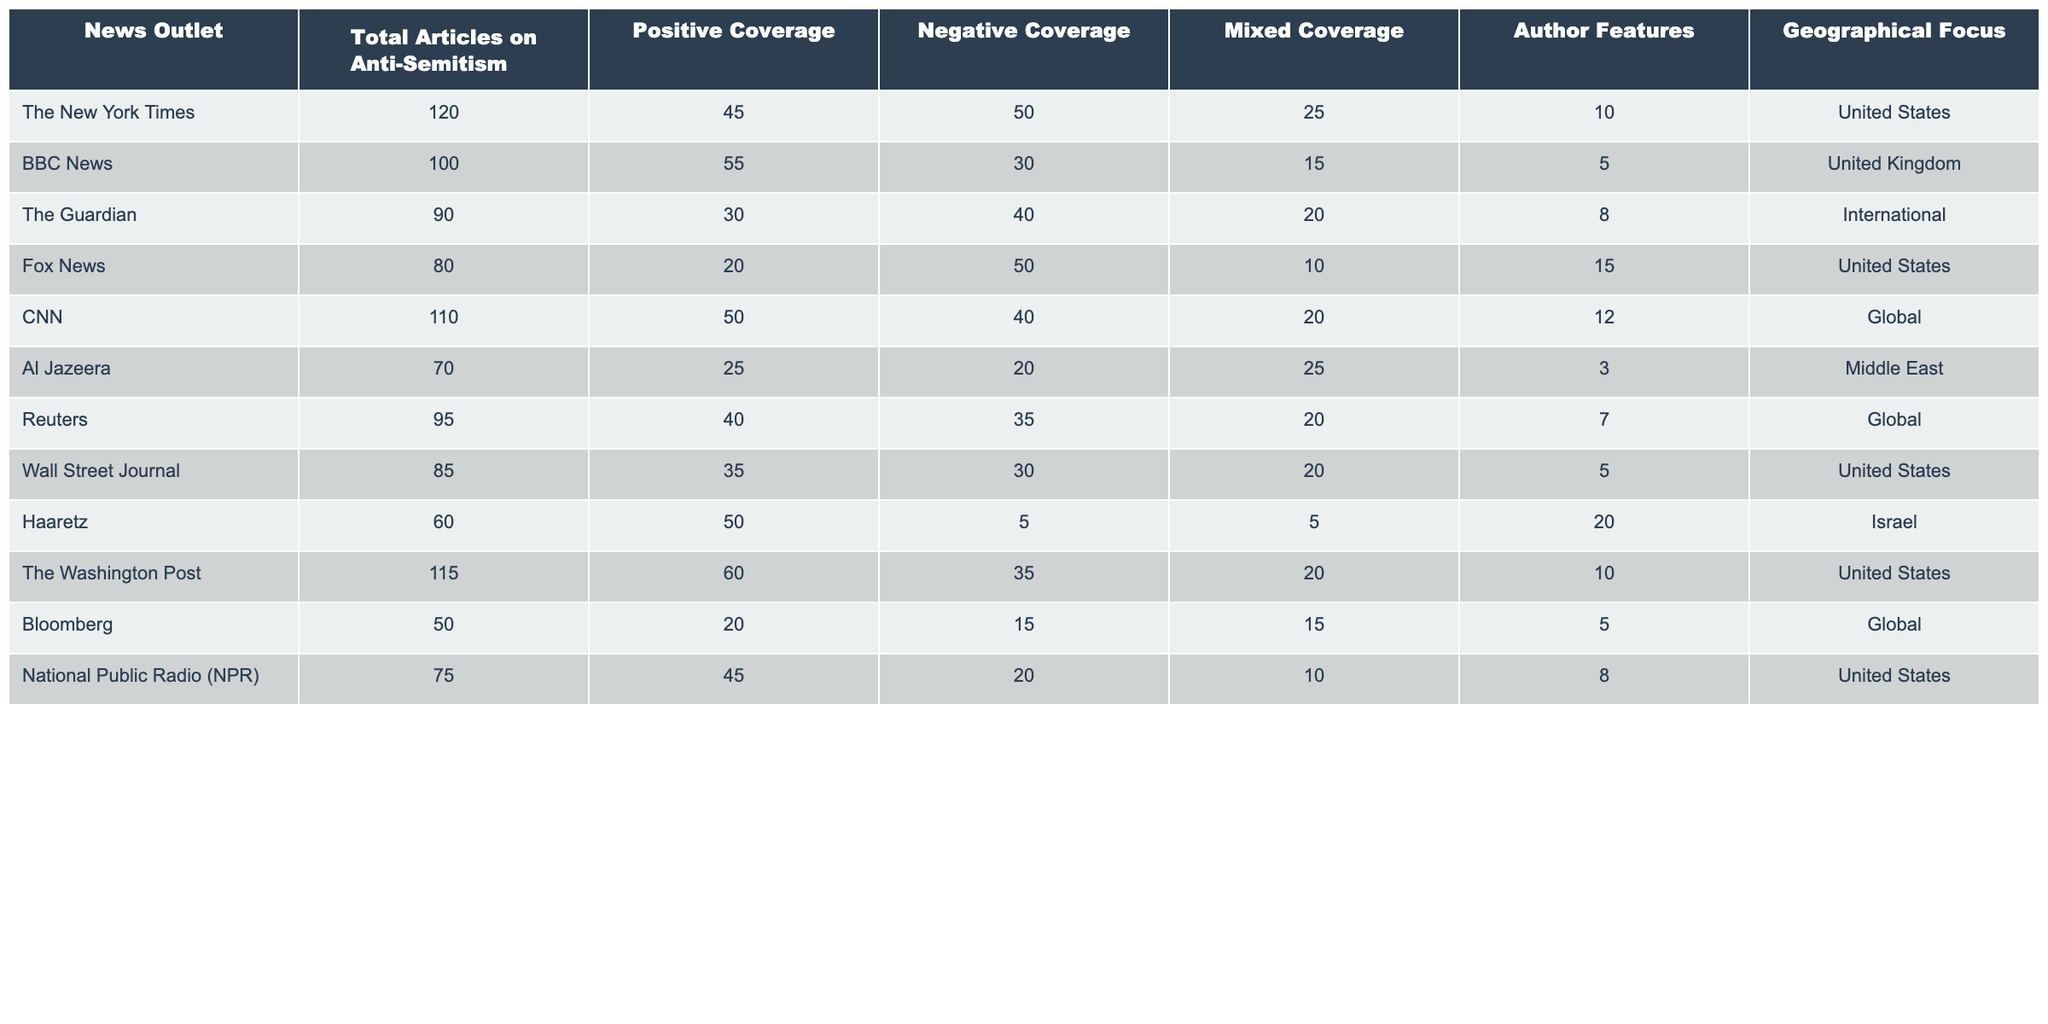What is the total number of articles on anti-Semitism published by The New York Times? The table shows that The New York Times published 120 articles on anti-Semitism.
Answer: 120 Which news outlet had the highest positive coverage of anti-Semitism? According to the table, The Washington Post has the highest positive coverage with 60 articles.
Answer: The Washington Post How many articles had negative coverage in total across all outlets? By summing the negative coverage values: 50 (NYT) + 30 (BBC) + 40 (Guardian) + 50 (Fox) + 40 (CNN) + 20 (Al Jazeera) + 35 (Reuters) + 30 (WSJ) + 5 (Haaretz) + 35 (WP) + 15 (Bloomberg) + 20 (NPR) = 450.
Answer: 450 Which outlet has a geographical focus on the Middle East and how many articles did it publish? Al Jazeera has a geographical focus on the Middle East and published 70 articles on anti-Semitism.
Answer: Al Jazeera, 70 What percentage of articles from The Guardian had mixed coverage? To calculate the percentage, the formula (Mixed Coverage articles / Total Articles) * 100 is used. (20 / 90) * 100 = 22.22%.
Answer: 22.22% If we combine the total articles from Fox News and Bloomberg, how many articles do we get? Fox News published 80 articles and Bloomberg published 50. Adding them gives: 80 + 50 = 130 articles.
Answer: 130 Did any outlet have more positive coverage than negative coverage? Yes, both The New York Times (45 positive, 50 negative) and Fox News (20 positive, 50 negative) had more negative coverage, but BBC News (55 positive, 30 negative) did.
Answer: Yes Which outlet published the least number of articles on anti-Semitism? The table indicates that Bloomberg published the least number of articles, with a total of 50.
Answer: Bloomberg What is the average number of author features among the news outlets? The average is calculated by summing the author features (10 + 5 + 8 + 15 + 12 + 3 + 7 + 5 + 20 + 10 + 5 + 8 = 100) and dividing by the number of outlets (12): 100 / 12 = 8.33.
Answer: 8.33 Which outlet had a mixed coverage percentage that exceeded 20%? Based on the table, The Guardian (20%), Al Jazeera (25%), CNN (20%), and The Washington Post (20%) had 20% or higher of mixed coverage.
Answer: The Guardian, Al Jazeera, CNN, The Washington Post 